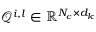Convert formula to latex. <formula><loc_0><loc_0><loc_500><loc_500>\mathcal { Q } ^ { i , l } \in \mathbb { R } ^ { N _ { c } \times d _ { k } }</formula> 